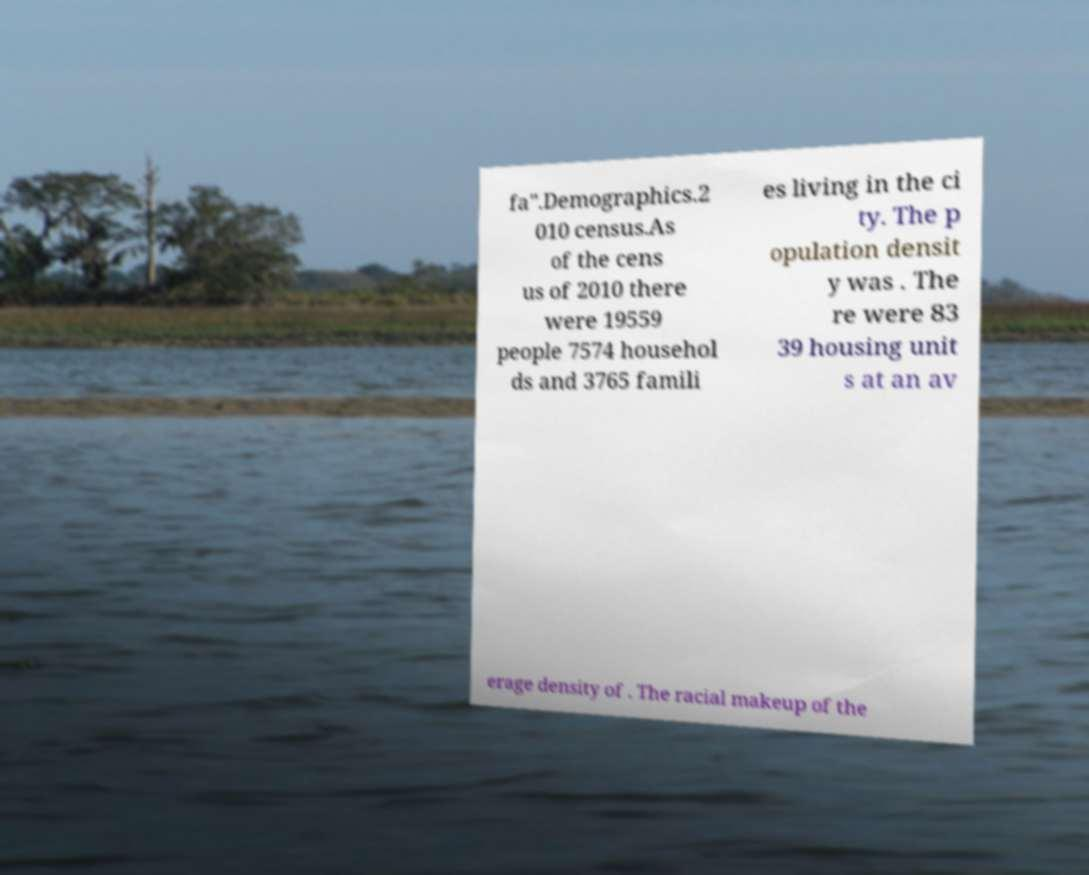Can you accurately transcribe the text from the provided image for me? fa".Demographics.2 010 census.As of the cens us of 2010 there were 19559 people 7574 househol ds and 3765 famili es living in the ci ty. The p opulation densit y was . The re were 83 39 housing unit s at an av erage density of . The racial makeup of the 